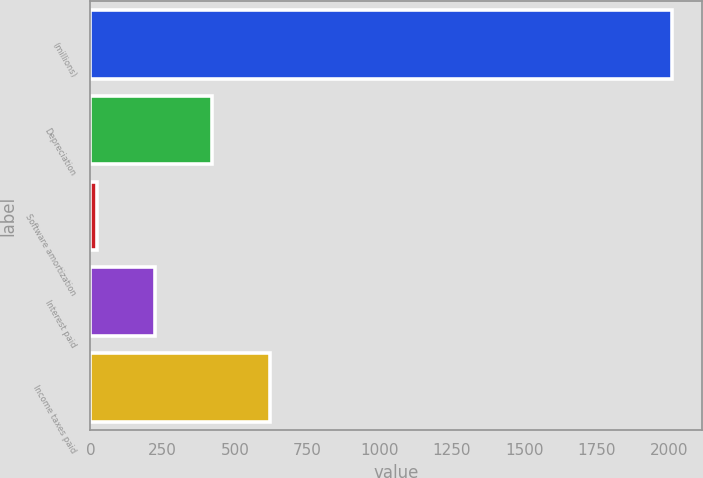Convert chart. <chart><loc_0><loc_0><loc_500><loc_500><bar_chart><fcel>(millions)<fcel>Depreciation<fcel>Software amortization<fcel>Interest paid<fcel>Income taxes paid<nl><fcel>2012<fcel>421.36<fcel>23.7<fcel>222.53<fcel>620.19<nl></chart> 